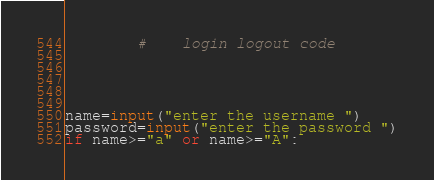Convert code to text. <code><loc_0><loc_0><loc_500><loc_500><_Python_>        #    login logout code





name=input("enter the username ")
password=input("enter the password ")
if name>="a" or name>="A":</code> 